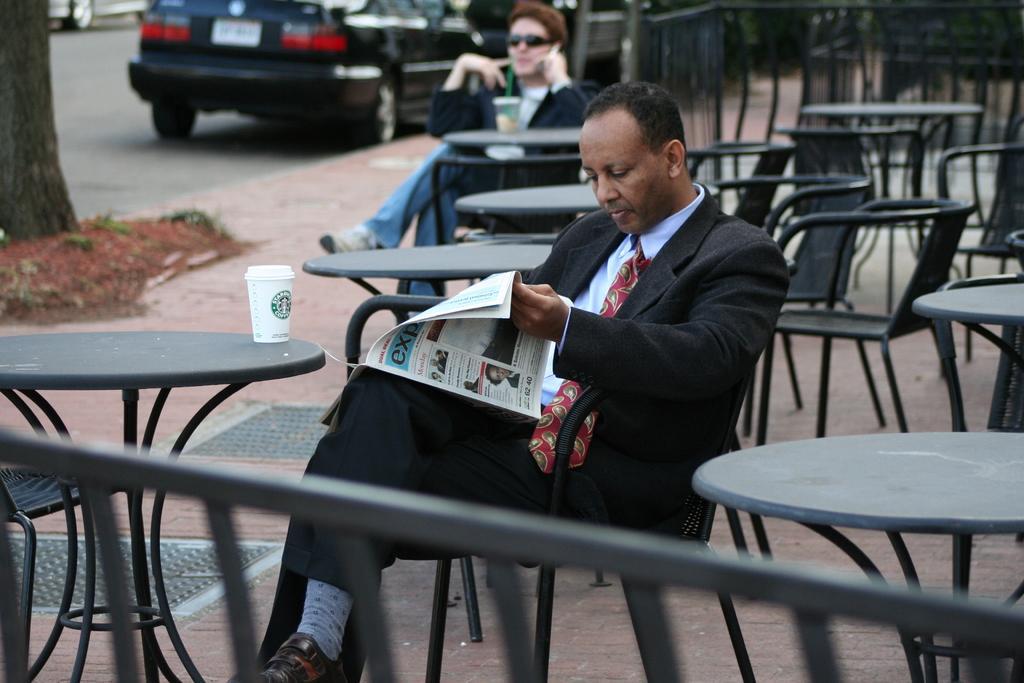Could you give a brief overview of what you see in this image? In this image, there are two persons sitting on chairs in front of the tables. These tables contains cups. There is a car at the top of this image. There is a person at the center of this image holding a paper with his hand. 